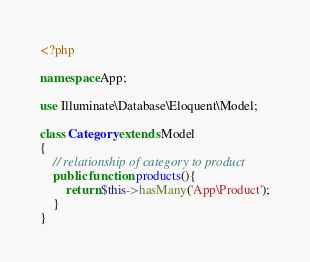Convert code to text. <code><loc_0><loc_0><loc_500><loc_500><_PHP_><?php

namespace App;

use Illuminate\Database\Eloquent\Model;

class Category extends Model
{
    // relationship of category to product
    public function products(){
        return $this->hasMany('App\Product');
    }
}
</code> 